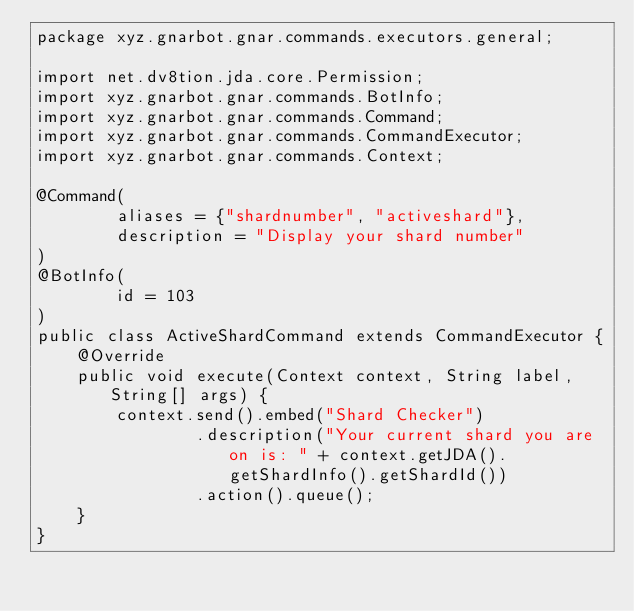Convert code to text. <code><loc_0><loc_0><loc_500><loc_500><_Java_>package xyz.gnarbot.gnar.commands.executors.general;

import net.dv8tion.jda.core.Permission;
import xyz.gnarbot.gnar.commands.BotInfo;
import xyz.gnarbot.gnar.commands.Command;
import xyz.gnarbot.gnar.commands.CommandExecutor;
import xyz.gnarbot.gnar.commands.Context;

@Command(
        aliases = {"shardnumber", "activeshard"},
        description = "Display your shard number"
)
@BotInfo(
        id = 103
)
public class ActiveShardCommand extends CommandExecutor {
    @Override
    public void execute(Context context, String label, String[] args) {
        context.send().embed("Shard Checker")
                .description("Your current shard you are on is: " + context.getJDA().getShardInfo().getShardId())
                .action().queue();
    }
}
</code> 